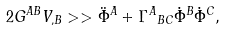<formula> <loc_0><loc_0><loc_500><loc_500>2 G ^ { A B } V _ { , B } > > \ddot { \Phi } ^ { A } + { \Gamma ^ { A } } _ { B C } \dot { \Phi } ^ { B } \dot { \Phi } ^ { C } ,</formula> 